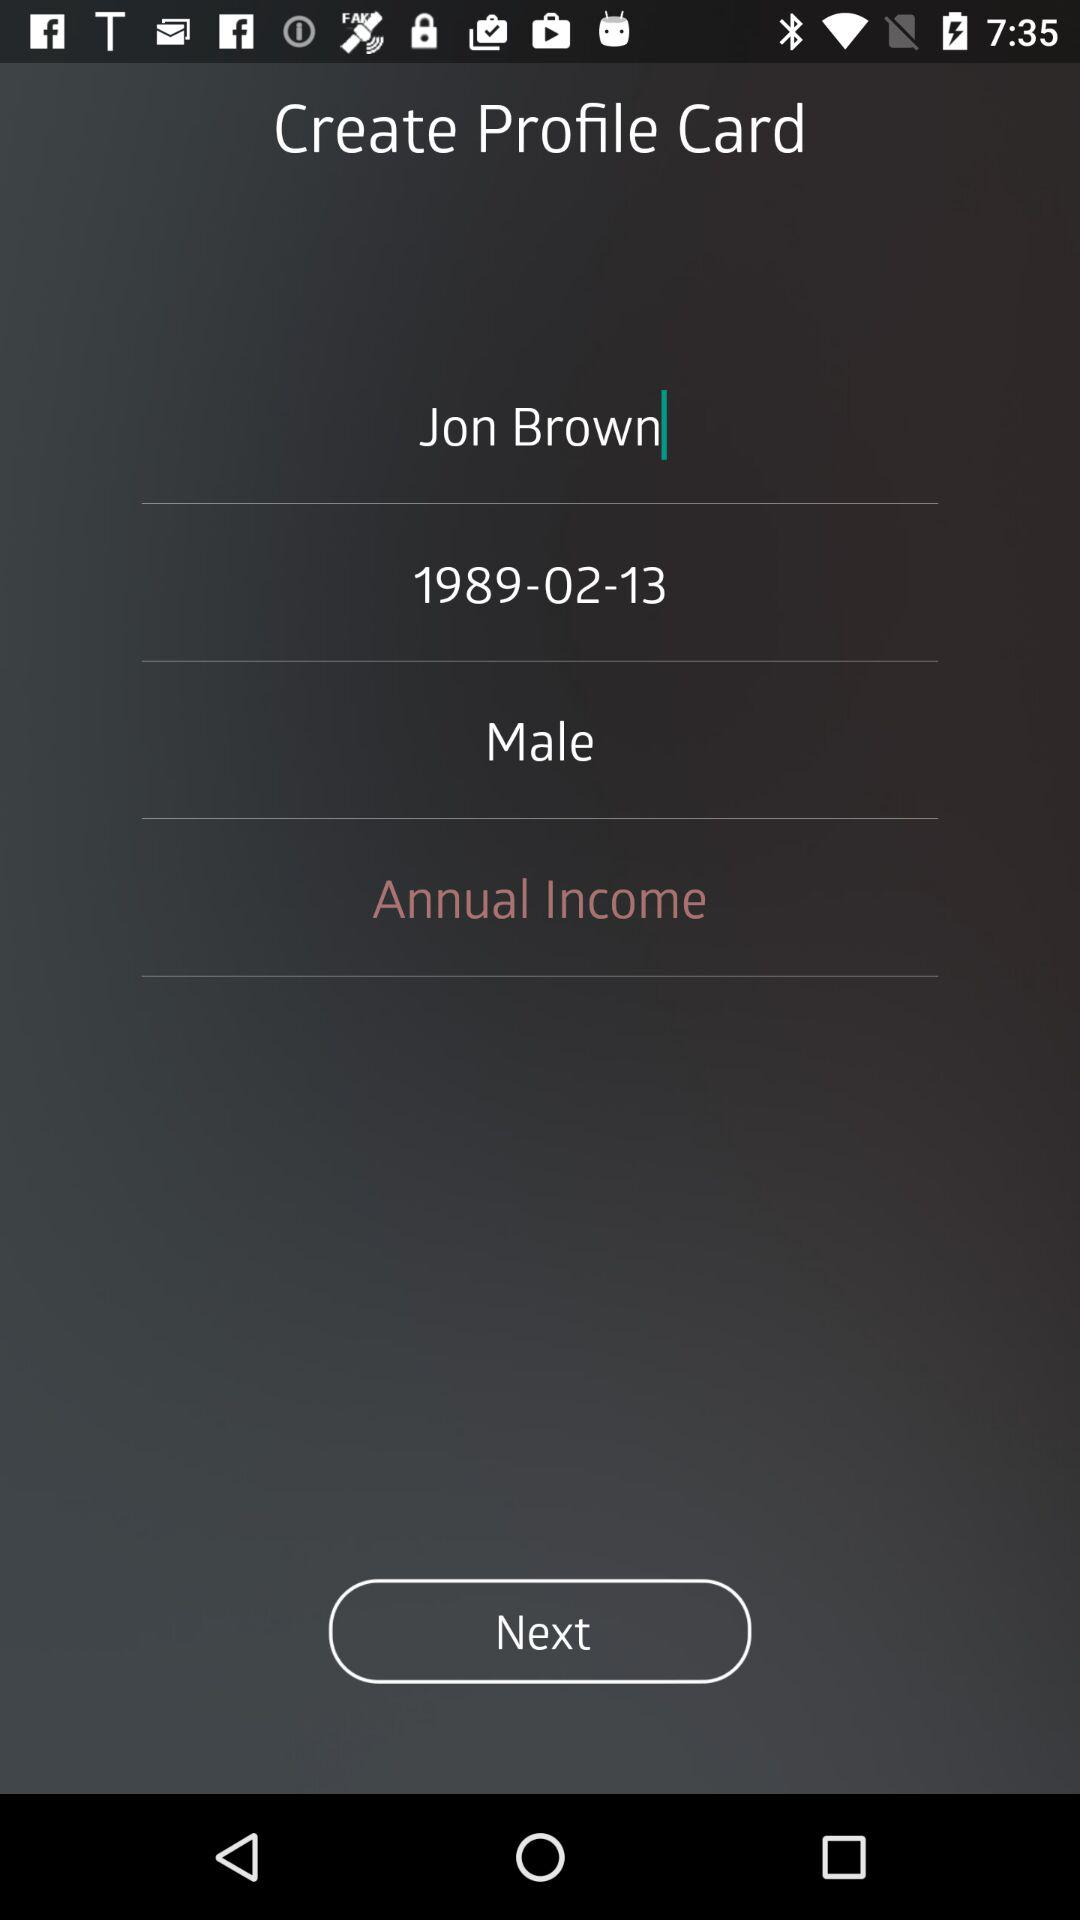What is the user name? The user name is Jon Brown. 